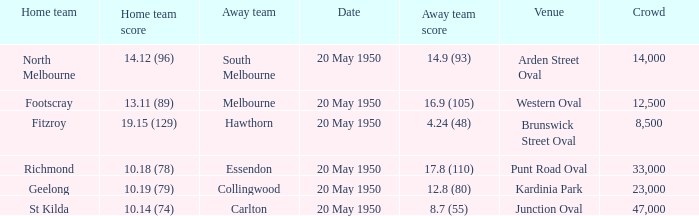What was the score for the away team when the home team was Fitzroy? 4.24 (48). 